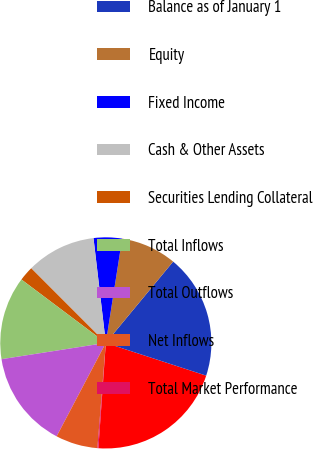Convert chart to OTSL. <chart><loc_0><loc_0><loc_500><loc_500><pie_chart><fcel>( In Billions)<fcel>Balance as of January 1<fcel>Equity<fcel>Fixed Income<fcel>Cash & Other Assets<fcel>Securities Lending Collateral<fcel>Total Inflows<fcel>Total Outflows<fcel>Net Inflows<fcel>Total Market Performance<nl><fcel>21.11%<fcel>19.01%<fcel>8.53%<fcel>4.34%<fcel>10.63%<fcel>2.25%<fcel>12.72%<fcel>14.82%<fcel>6.44%<fcel>0.15%<nl></chart> 